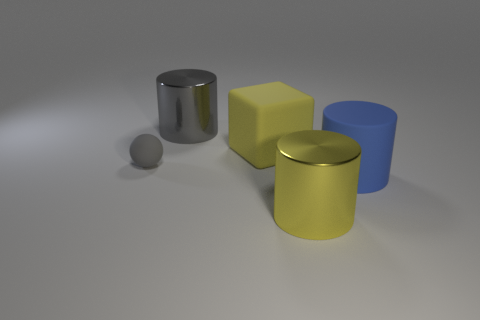What number of shiny cylinders are in front of the big metal cylinder in front of the gray matte thing?
Provide a succinct answer. 0. Are there fewer big cubes that are to the right of the big blue rubber cylinder than small brown metallic balls?
Make the answer very short. No. What is the shape of the shiny thing that is behind the big metal cylinder that is on the right side of the big metallic object that is behind the yellow metallic object?
Your answer should be compact. Cylinder. Is the big blue thing the same shape as the large gray thing?
Provide a succinct answer. Yes. What number of other objects are there of the same shape as the large blue thing?
Your answer should be compact. 2. The matte cylinder that is the same size as the yellow cube is what color?
Make the answer very short. Blue. Are there an equal number of matte blocks behind the big gray metallic object and gray spheres?
Make the answer very short. No. What shape is the thing that is both left of the blue object and in front of the small rubber object?
Your answer should be compact. Cylinder. Does the gray sphere have the same size as the blue object?
Provide a succinct answer. No. Are there any large cylinders that have the same material as the large block?
Your answer should be very brief. Yes. 